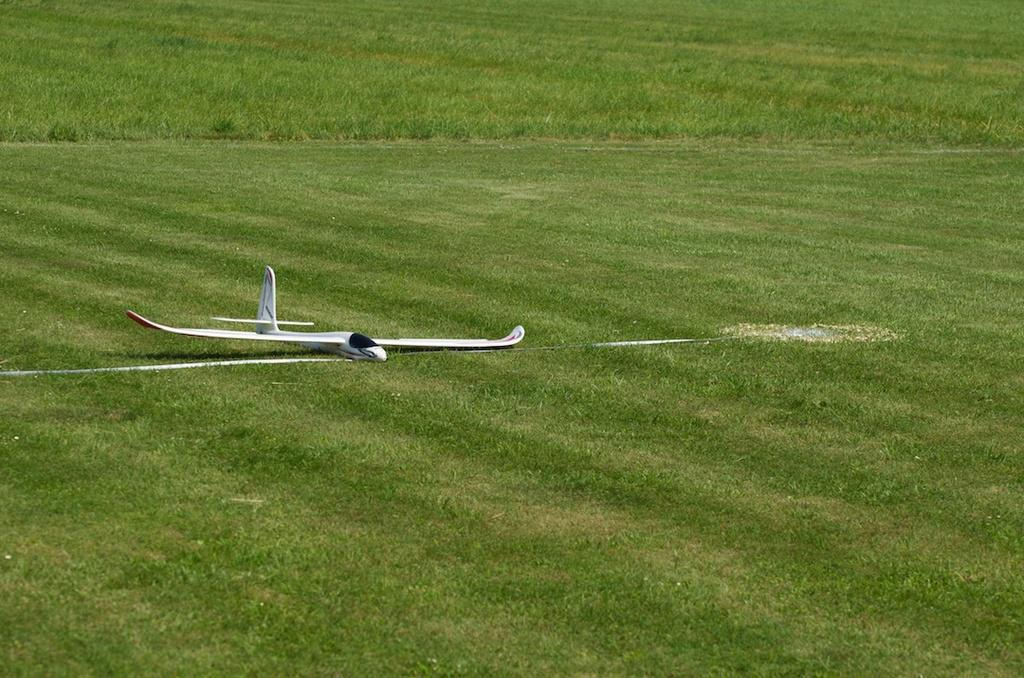What type of toy is present in the image? There is a toy airplane in the image. What type of surface is visible on the floor in the image? There is grass on the floor in the image. What type of cheese is present in the image? There is no cheese present in the image. What type of title is given to the toy airplane in the image? There is no title given to the toy airplane in the image. Is there a judge present in the image? There is no judge present in the image. 